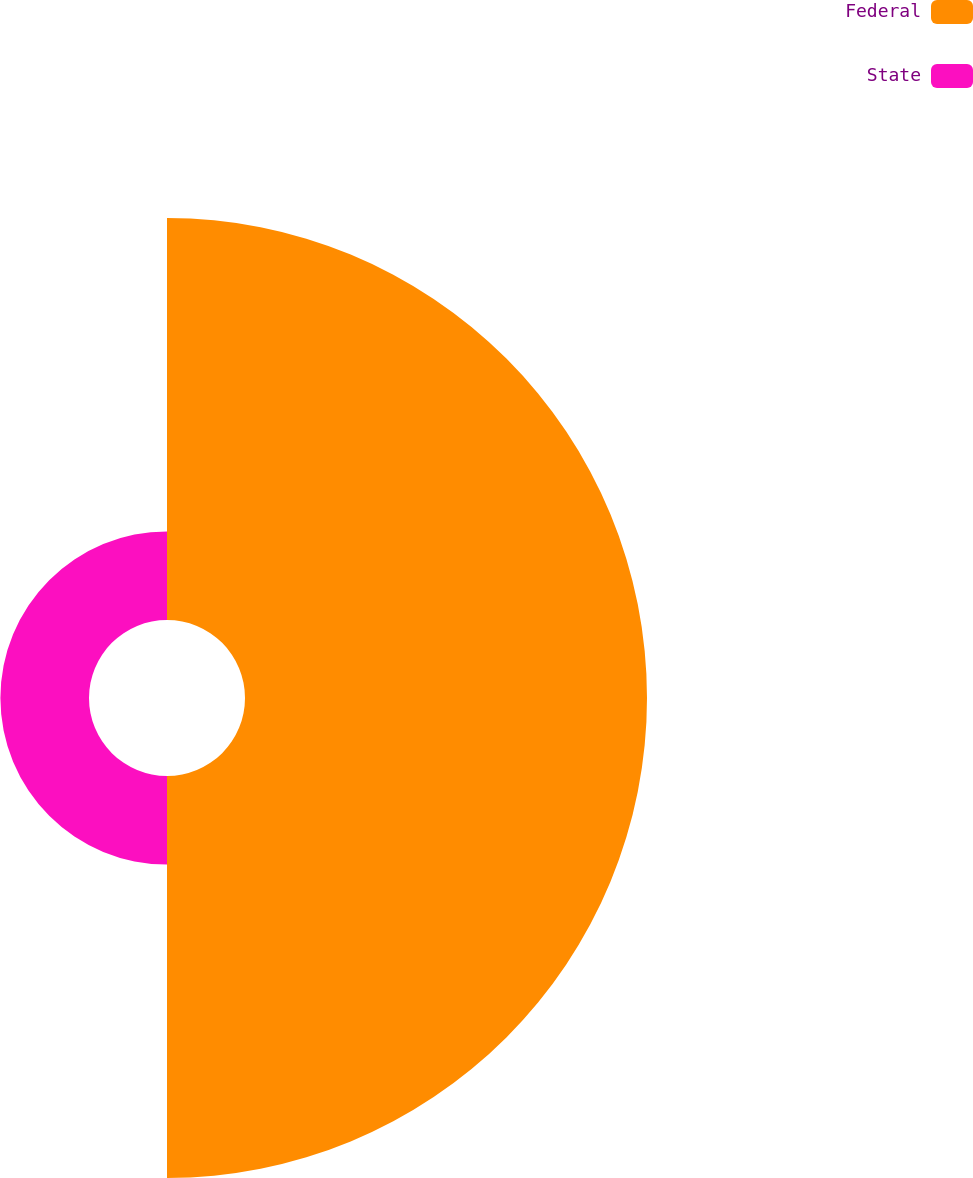Convert chart to OTSL. <chart><loc_0><loc_0><loc_500><loc_500><pie_chart><fcel>Federal<fcel>State<nl><fcel>81.94%<fcel>18.06%<nl></chart> 